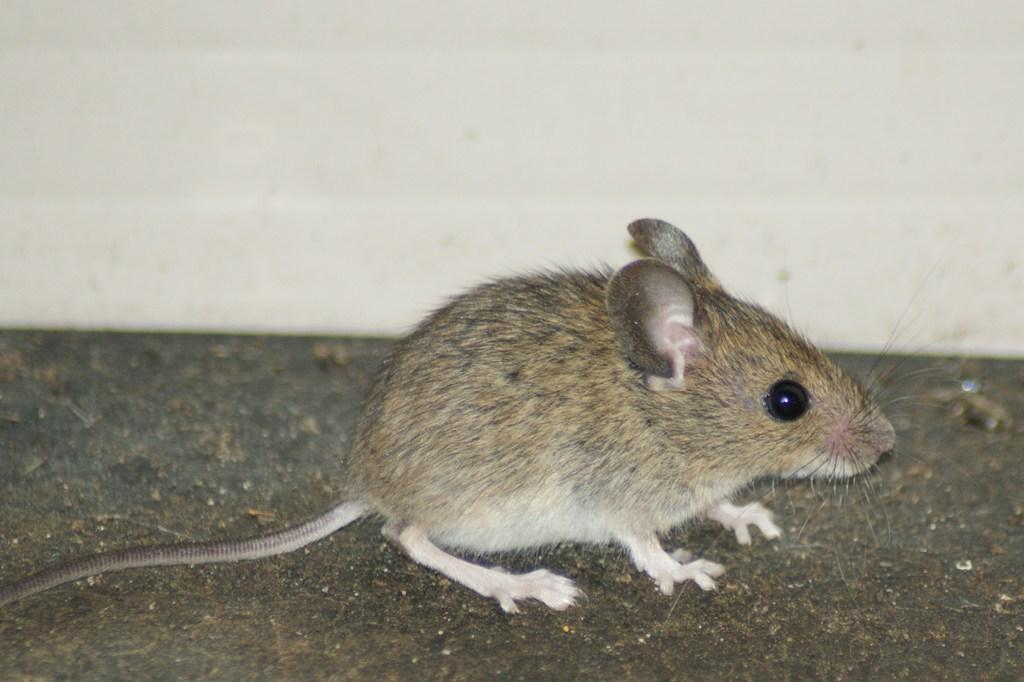What type of animal is in the image? There is a rat in the image. What is located on the ground in the image? There is an object on the ground in the image. What can be seen in the background of the image? There is a wall in the image. What type of vacation is the rat planning in the image? There is no indication in the image that the rat is planning a vacation, as rats do not plan vacations. 